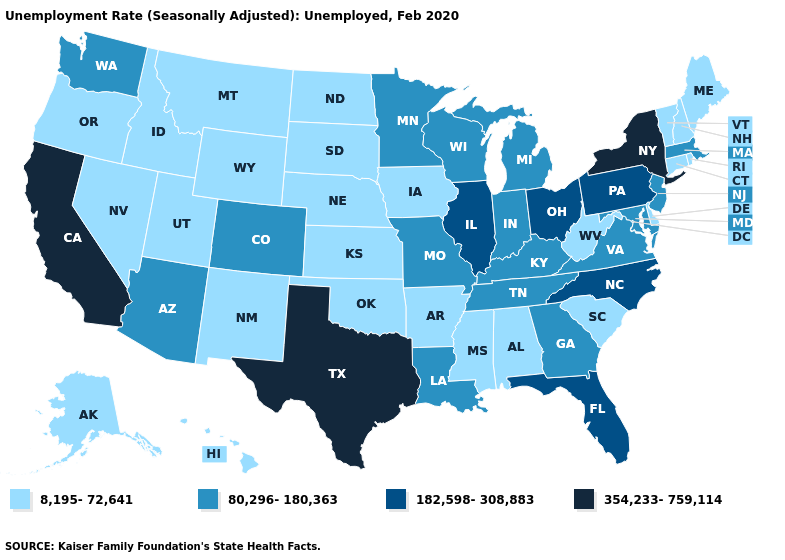Does New York have the highest value in the Northeast?
Answer briefly. Yes. Which states have the lowest value in the West?
Write a very short answer. Alaska, Hawaii, Idaho, Montana, Nevada, New Mexico, Oregon, Utah, Wyoming. Is the legend a continuous bar?
Quick response, please. No. Name the states that have a value in the range 182,598-308,883?
Write a very short answer. Florida, Illinois, North Carolina, Ohio, Pennsylvania. Among the states that border Illinois , which have the highest value?
Answer briefly. Indiana, Kentucky, Missouri, Wisconsin. What is the value of Kansas?
Short answer required. 8,195-72,641. Name the states that have a value in the range 8,195-72,641?
Be succinct. Alabama, Alaska, Arkansas, Connecticut, Delaware, Hawaii, Idaho, Iowa, Kansas, Maine, Mississippi, Montana, Nebraska, Nevada, New Hampshire, New Mexico, North Dakota, Oklahoma, Oregon, Rhode Island, South Carolina, South Dakota, Utah, Vermont, West Virginia, Wyoming. Does Colorado have a lower value than New Mexico?
Quick response, please. No. What is the value of Wyoming?
Give a very brief answer. 8,195-72,641. Does Louisiana have the lowest value in the USA?
Short answer required. No. What is the lowest value in the South?
Answer briefly. 8,195-72,641. Name the states that have a value in the range 80,296-180,363?
Write a very short answer. Arizona, Colorado, Georgia, Indiana, Kentucky, Louisiana, Maryland, Massachusetts, Michigan, Minnesota, Missouri, New Jersey, Tennessee, Virginia, Washington, Wisconsin. What is the value of Indiana?
Keep it brief. 80,296-180,363. Name the states that have a value in the range 354,233-759,114?
Keep it brief. California, New York, Texas. 